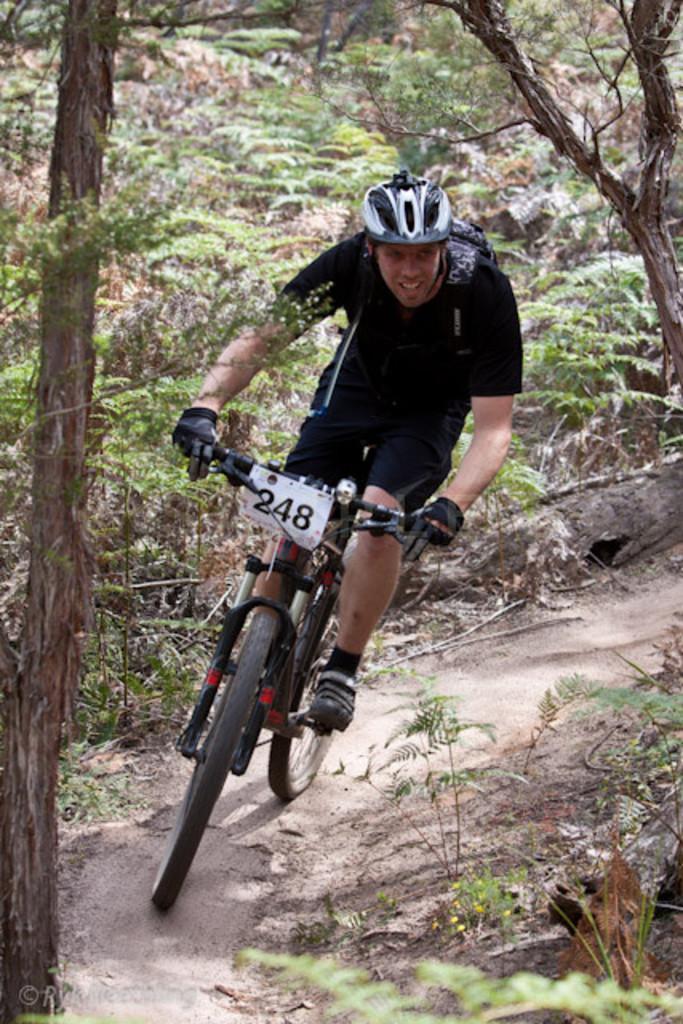Please provide a concise description of this image. There is a man riding a bicycle. In the background we can see plants and trees. 